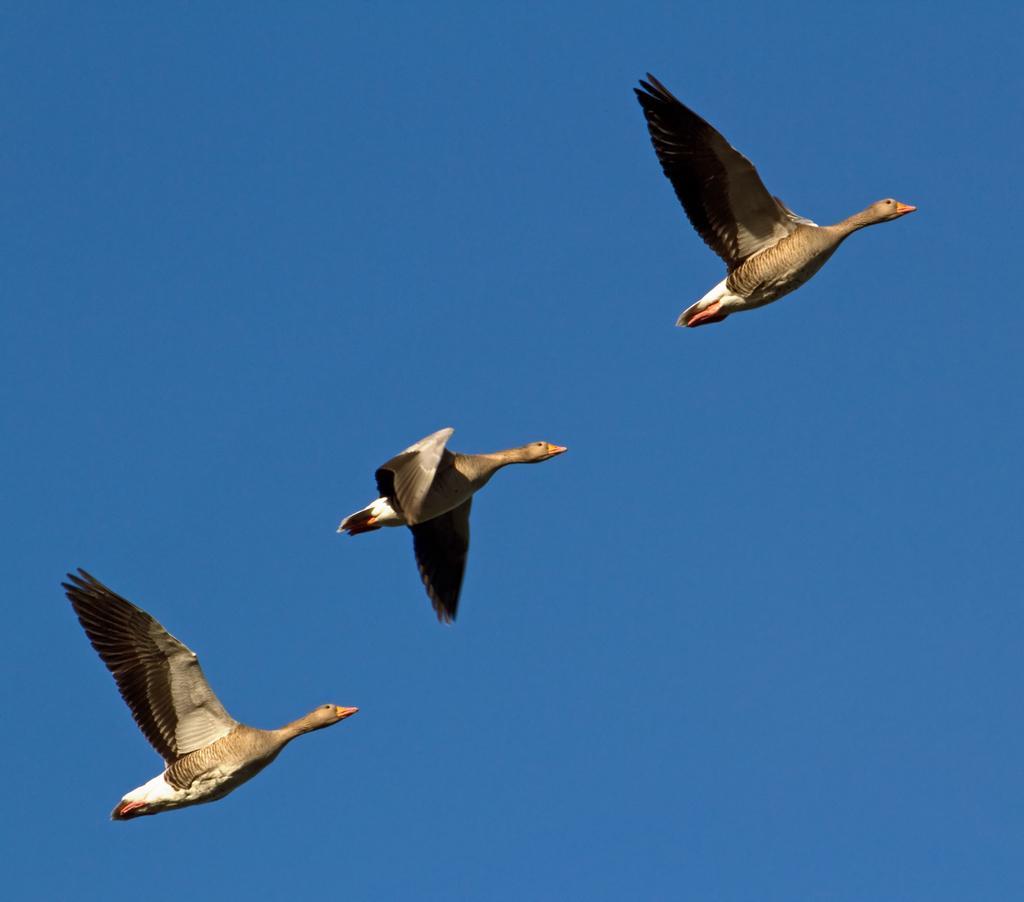How would you summarize this image in a sentence or two? This image is taken outdoors. In the background there is a sky. In the middle of the image three birds are flying in the sky. 